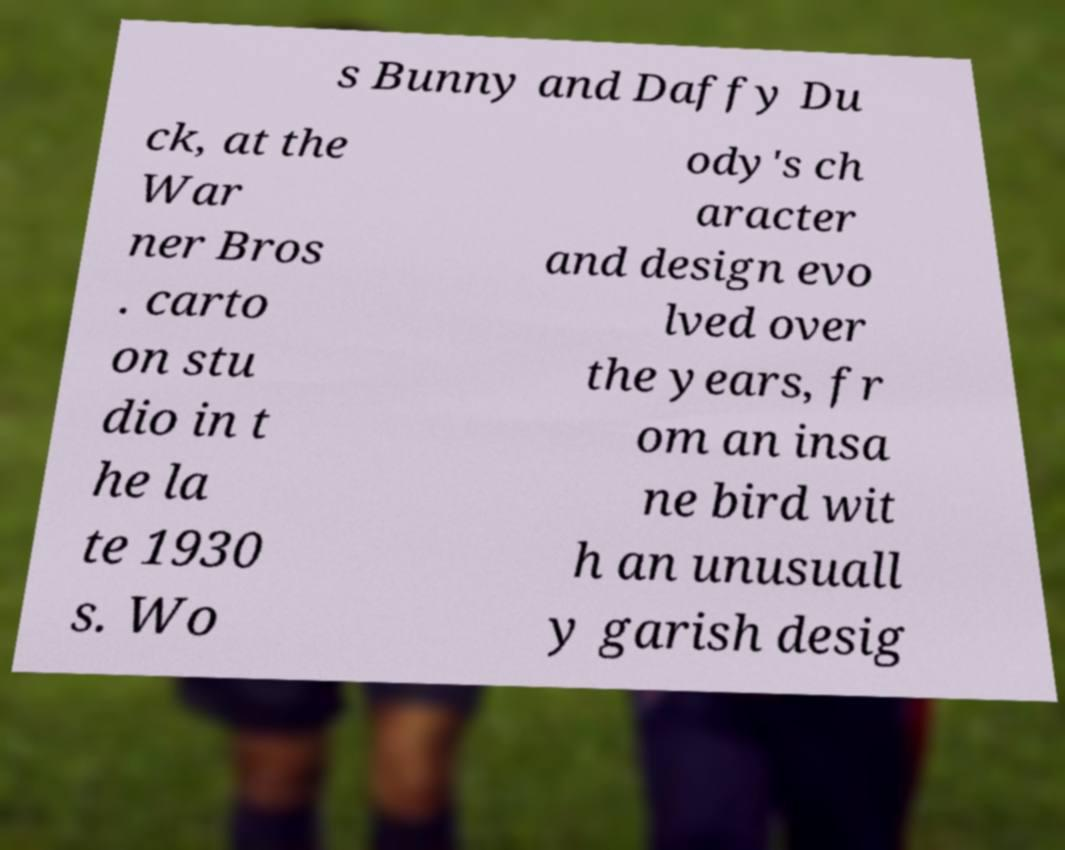Can you accurately transcribe the text from the provided image for me? s Bunny and Daffy Du ck, at the War ner Bros . carto on stu dio in t he la te 1930 s. Wo ody's ch aracter and design evo lved over the years, fr om an insa ne bird wit h an unusuall y garish desig 